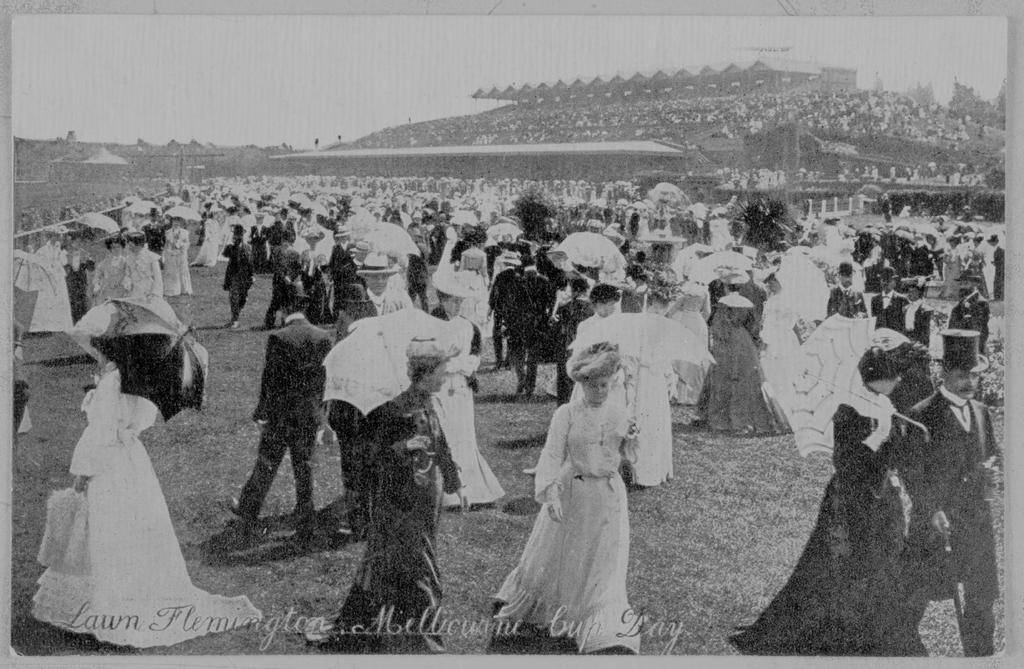What is the color scheme of the image? The image is black and white. What can be seen in the image? There is a crowd in the image. What are the people in the crowd holding? The people in the crowd are holding umbrellas. What type of copper bird can be seen in the image? There is no copper bird present in the image; it features a black and white crowd with people holding umbrellas. 